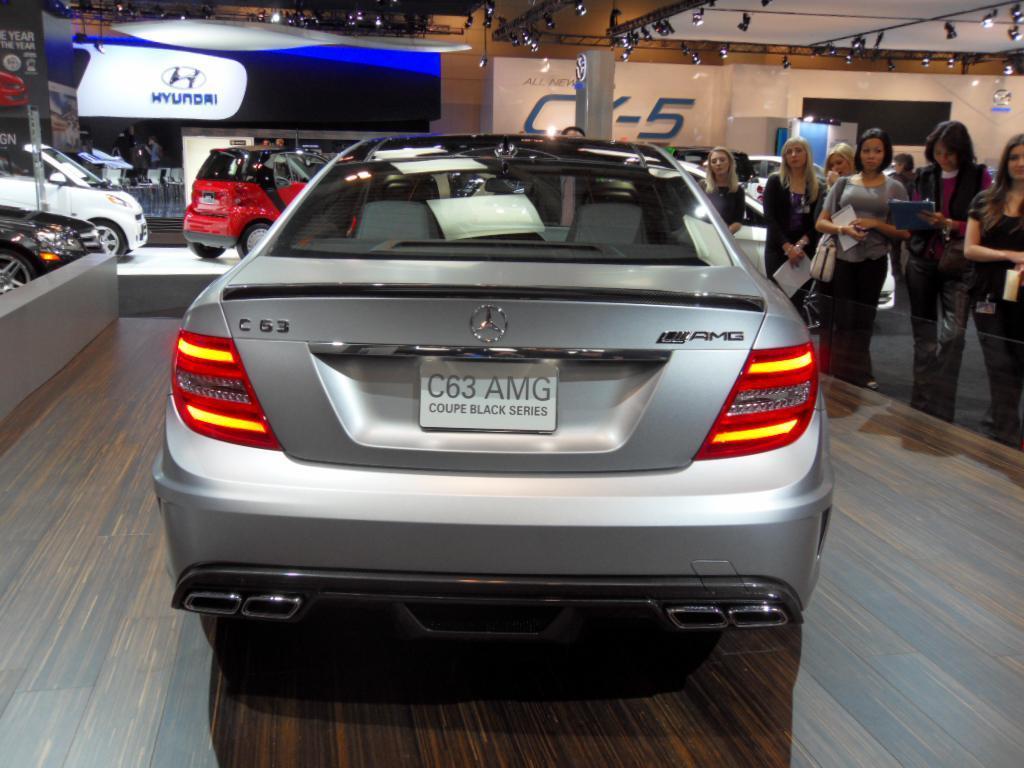Can you describe this image briefly? In this image, It looks like a car show with the cars. On the right side of the image, there are group of people standing. At the top of the image, I can see the lights attached to the lighting trusses. In the background, I can see the hoardings. 